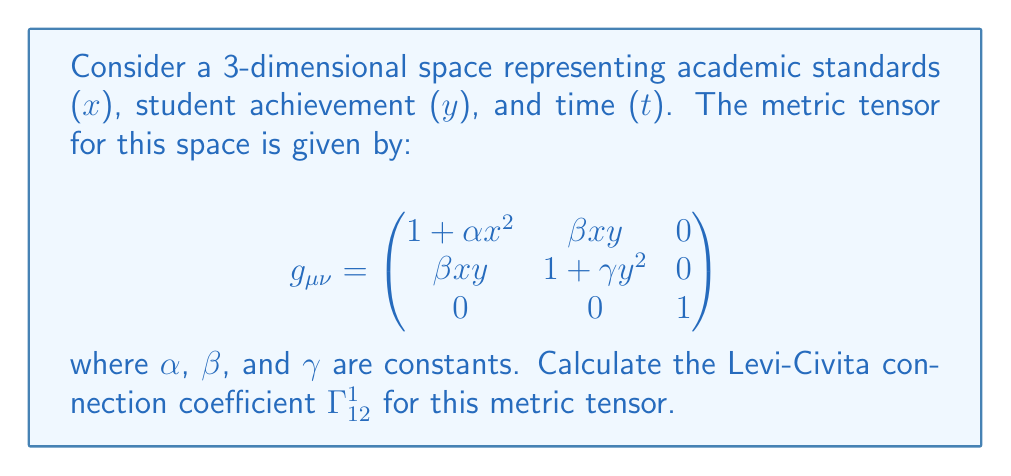Teach me how to tackle this problem. To calculate the Levi-Civita connection coefficient $\Gamma^1_{12}$, we'll use the formula:

$$\Gamma^{\lambda}_{\mu\nu} = \frac{1}{2}g^{\lambda\sigma}(\partial_\mu g_{\nu\sigma} + \partial_\nu g_{\mu\sigma} - \partial_\sigma g_{\mu\nu})$$

Steps:

1) First, we need to find the inverse metric tensor $g^{\mu\nu}$. For a 3x3 matrix, this is complex, but we only need $g^{11}$ for this calculation. Using the cofactor method:

   $$g^{11} = \frac{1}{\det(g_{\mu\nu})}((1+\gamma y^2)(1) - 0^2) = \frac{1+\gamma y^2}{\det(g_{\mu\nu})}$$

2) Now, we calculate the partial derivatives needed:

   $\partial_1 g_{2\sigma}$: $\frac{\partial}{\partial x}(\beta xy) = \beta y$
   $\partial_2 g_{1\sigma}$: $\frac{\partial}{\partial y}(\beta xy) = \beta x$
   $\partial_\sigma g_{12}$: $\frac{\partial}{\partial x}(\beta xy) = \beta y$

3) Substituting into the formula:

   $$\Gamma^1_{12} = \frac{1}{2}g^{11}(\partial_1 g_{2\sigma} + \partial_2 g_{1\sigma} - \partial_\sigma g_{12})$$
   $$= \frac{1}{2}\frac{1+\gamma y^2}{\det(g_{\mu\nu})}(\beta y + \beta x - \beta y)$$
   $$= \frac{1}{2}\frac{1+\gamma y^2}{\det(g_{\mu\nu})}(\beta x)$$
   $$= \frac{\beta x(1+\gamma y^2)}{2\det(g_{\mu\nu})}$$

4) The determinant $\det(g_{\mu\nu})$ is a constant factor in this context, as it doesn't affect the functional form of $\Gamma^1_{12}$.
Answer: $\Gamma^1_{12} = \frac{\beta x(1+\gamma y^2)}{2\det(g_{\mu\nu})}$ 